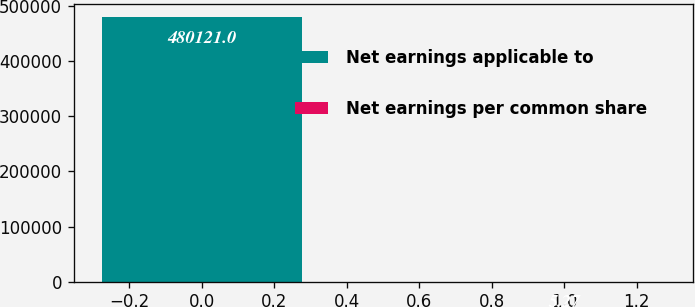Convert chart to OTSL. <chart><loc_0><loc_0><loc_500><loc_500><bar_chart><fcel>Net earnings applicable to<fcel>Net earnings per common share<nl><fcel>480121<fcel>5.27<nl></chart> 